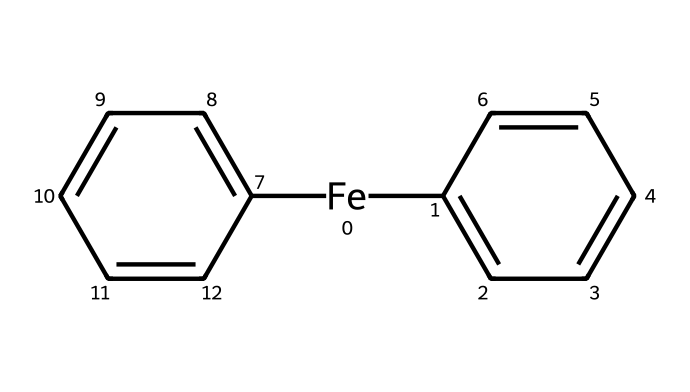What is the central metal atom in ferrocene? By analyzing the SMILES representation, the part that represents the metal atom is [Fe], indicating that iron is the central metal in this organometallic compound.
Answer: iron How many cyclopentadienyl rings are present in ferrocene? The structure shows two benzene-like rings, which can be inferred from the two occurrences of C1=CC=CC=C1 in the SMILES notation, reflecting the two cyclopentadienyl ligands.
Answer: two What is the oxidation state of iron in ferrocene? In ferrocene, iron typically has an oxidation state of +2, as it bonds with two negatively charged cyclopentadienyl anions (C5H5) during coordination chemistry.
Answer: +2 How many carbon atoms are in ferrocene? Each cyclopentadienyl ring has 5 carbon atoms, and since there are two of them, the total can be calculated as 5 x 2, giving us 10 carbon atoms in ferrocene.
Answer: ten What type of bonding is mainly responsible for the stability of ferrocene? The stability of ferrocene is primarily due to the delocalized π-electron system from the cyclopentadienyl rings, which creates a robust interaction with the iron center through π-backbonding.
Answer: π-bonding What class of compounds does ferrocene belong to? Ferrocene is classified as an organometallic compound because it features a metal (iron) bonded to carbon-containing compounds (the cyclopentadienyl rings).
Answer: organometallic 